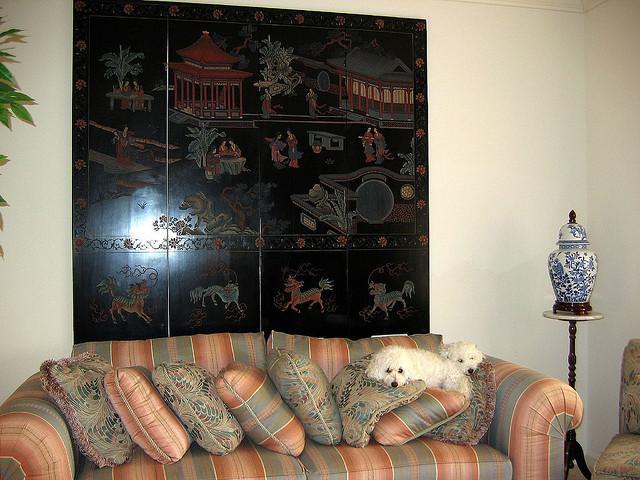How many dogs are on the couch?
Give a very brief answer. 2. 